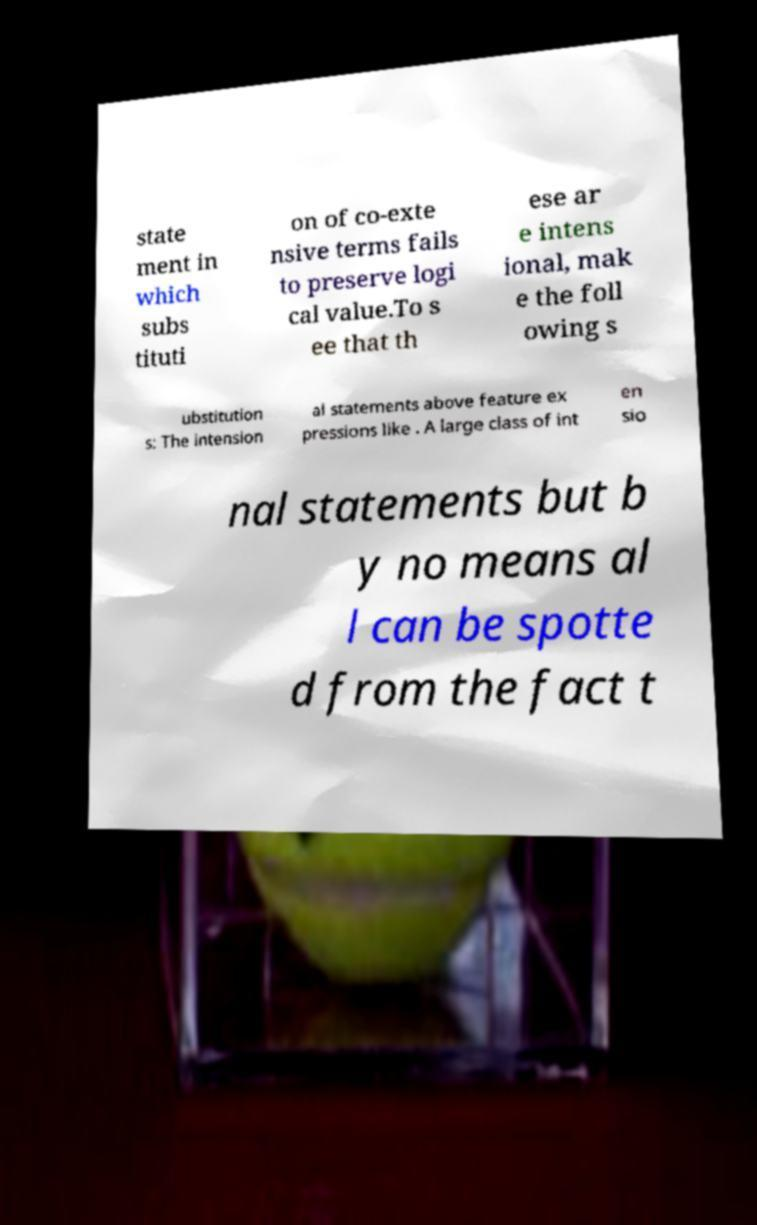I need the written content from this picture converted into text. Can you do that? state ment in which subs tituti on of co-exte nsive terms fails to preserve logi cal value.To s ee that th ese ar e intens ional, mak e the foll owing s ubstitution s: The intension al statements above feature ex pressions like . A large class of int en sio nal statements but b y no means al l can be spotte d from the fact t 